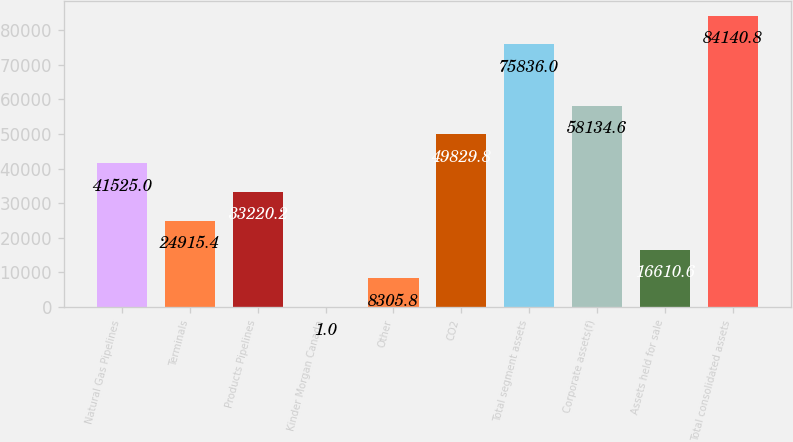Convert chart. <chart><loc_0><loc_0><loc_500><loc_500><bar_chart><fcel>Natural Gas Pipelines<fcel>Terminals<fcel>Products Pipelines<fcel>Kinder Morgan Canada<fcel>Other<fcel>CO2<fcel>Total segment assets<fcel>Corporate assets(f)<fcel>Assets held for sale<fcel>Total consolidated assets<nl><fcel>41525<fcel>24915.4<fcel>33220.2<fcel>1<fcel>8305.8<fcel>49829.8<fcel>75836<fcel>58134.6<fcel>16610.6<fcel>84140.8<nl></chart> 